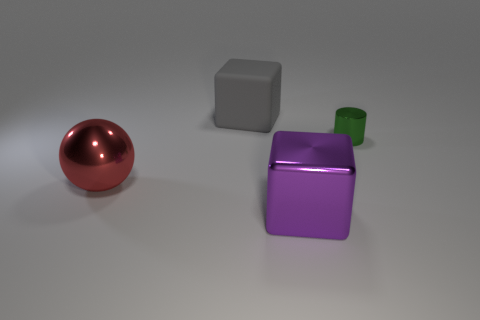Subtract all purple cylinders. Subtract all gray balls. How many cylinders are left? 1 Add 2 gray cylinders. How many objects exist? 6 Subtract all cylinders. How many objects are left? 3 Add 4 blue rubber things. How many blue rubber things exist? 4 Subtract 0 green cubes. How many objects are left? 4 Subtract all small cyan balls. Subtract all large gray cubes. How many objects are left? 3 Add 1 big red things. How many big red things are left? 2 